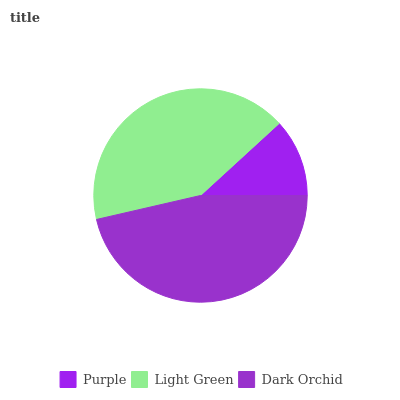Is Purple the minimum?
Answer yes or no. Yes. Is Dark Orchid the maximum?
Answer yes or no. Yes. Is Light Green the minimum?
Answer yes or no. No. Is Light Green the maximum?
Answer yes or no. No. Is Light Green greater than Purple?
Answer yes or no. Yes. Is Purple less than Light Green?
Answer yes or no. Yes. Is Purple greater than Light Green?
Answer yes or no. No. Is Light Green less than Purple?
Answer yes or no. No. Is Light Green the high median?
Answer yes or no. Yes. Is Light Green the low median?
Answer yes or no. Yes. Is Dark Orchid the high median?
Answer yes or no. No. Is Dark Orchid the low median?
Answer yes or no. No. 